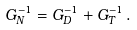<formula> <loc_0><loc_0><loc_500><loc_500>G _ { N } ^ { - 1 } = G _ { D } ^ { - 1 } + G _ { T } ^ { - 1 } \, .</formula> 